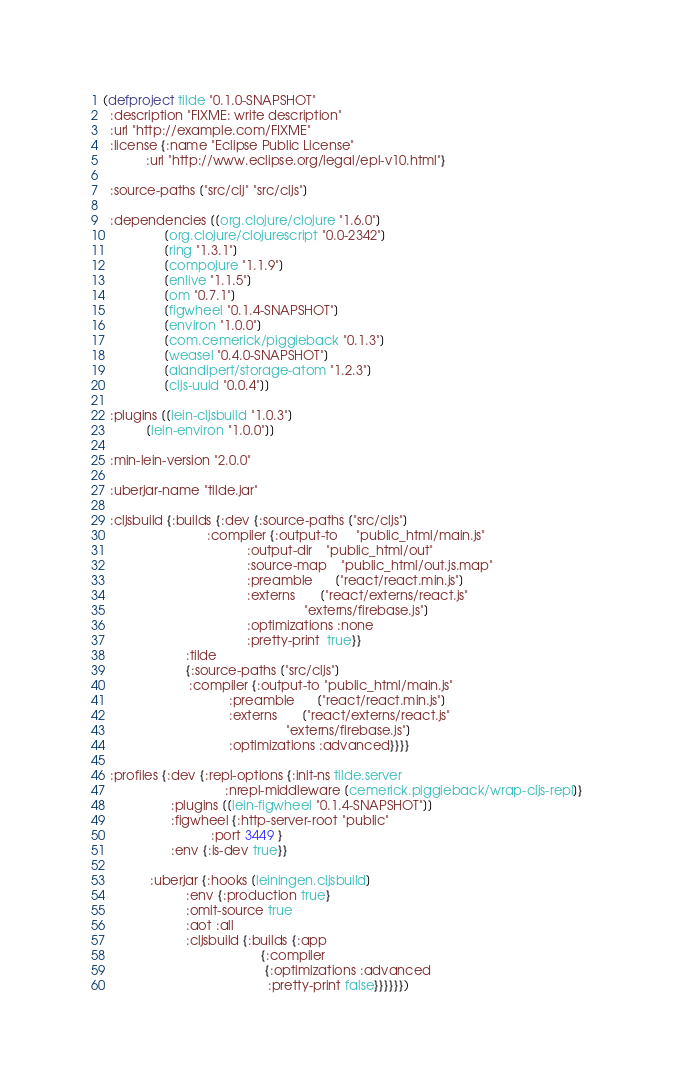Convert code to text. <code><loc_0><loc_0><loc_500><loc_500><_Clojure_>(defproject tilde "0.1.0-SNAPSHOT"
  :description "FIXME: write description"
  :url "http://example.com/FIXME"
  :license {:name "Eclipse Public License"
            :url "http://www.eclipse.org/legal/epl-v10.html"}

  :source-paths ["src/clj" "src/cljs"]

  :dependencies [[org.clojure/clojure "1.6.0"]
                 [org.clojure/clojurescript "0.0-2342"]
                 [ring "1.3.1"]
                 [compojure "1.1.9"]
                 [enlive "1.1.5"]
                 [om "0.7.1"]
                 [figwheel "0.1.4-SNAPSHOT"]
                 [environ "1.0.0"]
                 [com.cemerick/piggieback "0.1.3"]
                 [weasel "0.4.0-SNAPSHOT"]
                 [alandipert/storage-atom "1.2.3"]
                 [cljs-uuid "0.0.4"]]

  :plugins [[lein-cljsbuild "1.0.3"]
            [lein-environ "1.0.0"]]

  :min-lein-version "2.0.0"

  :uberjar-name "tilde.jar"

  :cljsbuild {:builds {:dev {:source-paths ["src/cljs"]
                             :compiler {:output-to     "public_html/main.js"
                                        :output-dir    "public_html/out"
                                        :source-map    "public_html/out.js.map"
                                        :preamble      ["react/react.min.js"]
                                        :externs       ["react/externs/react.js"
                                                        "externs/firebase.js"]
                                        :optimizations :none
                                        :pretty-print  true}}
                       :tilde
                       {:source-paths ["src/cljs"]
                        :compiler {:output-to "public_html/main.js"
                                   :preamble      ["react/react.min.js"]
                                   :externs       ["react/externs/react.js"
                                                   "externs/firebase.js"]
                                   :optimizations :advanced}}}}

  :profiles {:dev {:repl-options {:init-ns tilde.server
                                  :nrepl-middleware [cemerick.piggieback/wrap-cljs-repl]}
                   :plugins [[lein-figwheel "0.1.4-SNAPSHOT"]]
                   :figwheel {:http-server-root "public"
                              :port 3449 }
                   :env {:is-dev true}}

             :uberjar {:hooks [leiningen.cljsbuild]
                       :env {:production true}
                       :omit-source true
                       :aot :all
                       :cljsbuild {:builds {:app
                                            {:compiler
                                             {:optimizations :advanced
                                              :pretty-print false}}}}}})
</code> 